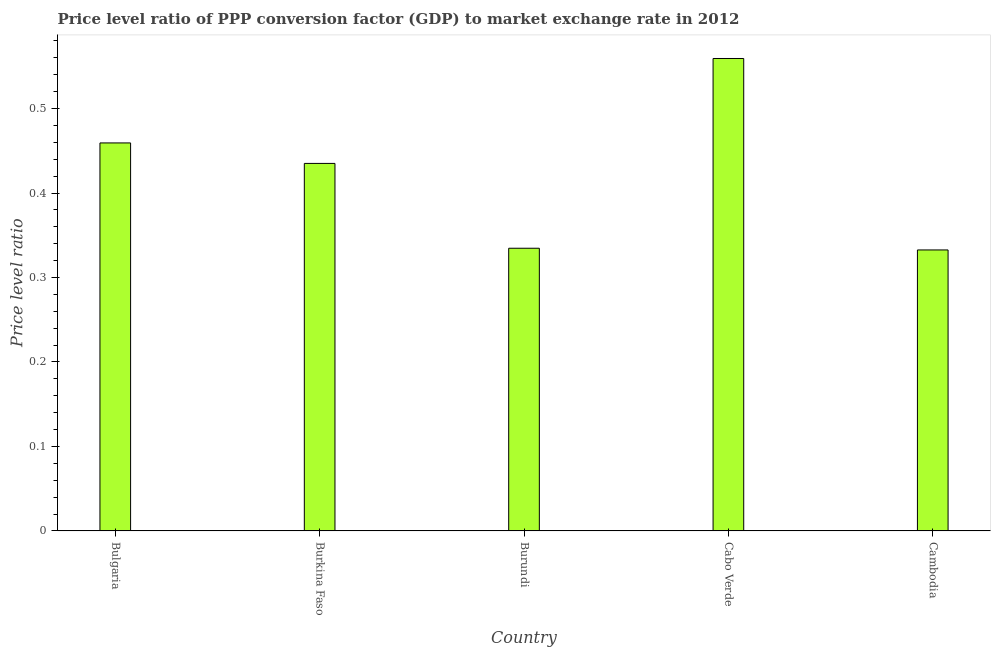Does the graph contain any zero values?
Provide a short and direct response. No. Does the graph contain grids?
Keep it short and to the point. No. What is the title of the graph?
Keep it short and to the point. Price level ratio of PPP conversion factor (GDP) to market exchange rate in 2012. What is the label or title of the X-axis?
Provide a succinct answer. Country. What is the label or title of the Y-axis?
Give a very brief answer. Price level ratio. What is the price level ratio in Burundi?
Ensure brevity in your answer.  0.33. Across all countries, what is the maximum price level ratio?
Make the answer very short. 0.56. Across all countries, what is the minimum price level ratio?
Give a very brief answer. 0.33. In which country was the price level ratio maximum?
Give a very brief answer. Cabo Verde. In which country was the price level ratio minimum?
Ensure brevity in your answer.  Cambodia. What is the sum of the price level ratio?
Give a very brief answer. 2.12. What is the difference between the price level ratio in Burundi and Cambodia?
Keep it short and to the point. 0. What is the average price level ratio per country?
Offer a very short reply. 0.42. What is the median price level ratio?
Your answer should be very brief. 0.44. In how many countries, is the price level ratio greater than 0.42 ?
Your response must be concise. 3. What is the ratio of the price level ratio in Cabo Verde to that in Cambodia?
Provide a short and direct response. 1.68. What is the difference between the highest and the second highest price level ratio?
Give a very brief answer. 0.1. Is the sum of the price level ratio in Bulgaria and Burundi greater than the maximum price level ratio across all countries?
Offer a very short reply. Yes. What is the difference between the highest and the lowest price level ratio?
Ensure brevity in your answer.  0.23. In how many countries, is the price level ratio greater than the average price level ratio taken over all countries?
Offer a terse response. 3. How many bars are there?
Your response must be concise. 5. What is the difference between two consecutive major ticks on the Y-axis?
Your answer should be very brief. 0.1. Are the values on the major ticks of Y-axis written in scientific E-notation?
Make the answer very short. No. What is the Price level ratio of Bulgaria?
Your response must be concise. 0.46. What is the Price level ratio of Burkina Faso?
Your answer should be very brief. 0.44. What is the Price level ratio in Burundi?
Ensure brevity in your answer.  0.33. What is the Price level ratio of Cabo Verde?
Ensure brevity in your answer.  0.56. What is the Price level ratio of Cambodia?
Provide a short and direct response. 0.33. What is the difference between the Price level ratio in Bulgaria and Burkina Faso?
Ensure brevity in your answer.  0.02. What is the difference between the Price level ratio in Bulgaria and Burundi?
Your response must be concise. 0.12. What is the difference between the Price level ratio in Bulgaria and Cabo Verde?
Make the answer very short. -0.1. What is the difference between the Price level ratio in Bulgaria and Cambodia?
Ensure brevity in your answer.  0.13. What is the difference between the Price level ratio in Burkina Faso and Burundi?
Ensure brevity in your answer.  0.1. What is the difference between the Price level ratio in Burkina Faso and Cabo Verde?
Your answer should be compact. -0.12. What is the difference between the Price level ratio in Burkina Faso and Cambodia?
Offer a terse response. 0.1. What is the difference between the Price level ratio in Burundi and Cabo Verde?
Make the answer very short. -0.22. What is the difference between the Price level ratio in Burundi and Cambodia?
Your answer should be compact. 0. What is the difference between the Price level ratio in Cabo Verde and Cambodia?
Keep it short and to the point. 0.23. What is the ratio of the Price level ratio in Bulgaria to that in Burkina Faso?
Provide a short and direct response. 1.06. What is the ratio of the Price level ratio in Bulgaria to that in Burundi?
Your answer should be compact. 1.37. What is the ratio of the Price level ratio in Bulgaria to that in Cabo Verde?
Offer a terse response. 0.82. What is the ratio of the Price level ratio in Bulgaria to that in Cambodia?
Provide a succinct answer. 1.38. What is the ratio of the Price level ratio in Burkina Faso to that in Cabo Verde?
Your answer should be very brief. 0.78. What is the ratio of the Price level ratio in Burkina Faso to that in Cambodia?
Offer a very short reply. 1.31. What is the ratio of the Price level ratio in Burundi to that in Cabo Verde?
Your response must be concise. 0.6. What is the ratio of the Price level ratio in Cabo Verde to that in Cambodia?
Give a very brief answer. 1.68. 